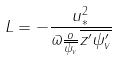Convert formula to latex. <formula><loc_0><loc_0><loc_500><loc_500>L = - \frac { u _ { * } ^ { 2 } } { \varpi \frac { o } { \overline { \psi _ { v } } } \overline { z ^ { \prime } \psi _ { v } ^ { \prime } } }</formula> 